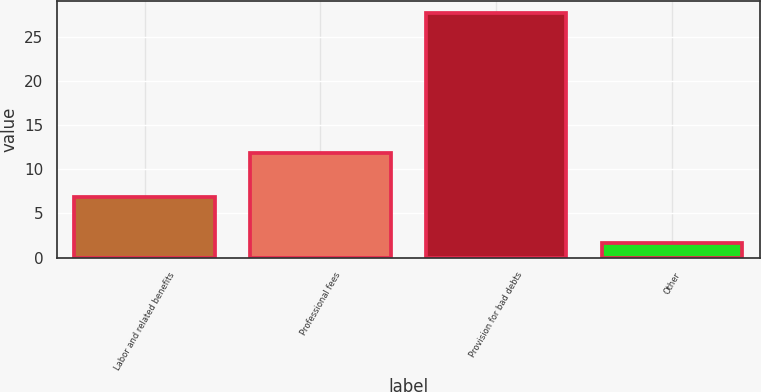<chart> <loc_0><loc_0><loc_500><loc_500><bar_chart><fcel>Labor and related benefits<fcel>Professional fees<fcel>Provision for bad debts<fcel>Other<nl><fcel>6.9<fcel>11.9<fcel>27.7<fcel>1.7<nl></chart> 